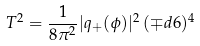Convert formula to latex. <formula><loc_0><loc_0><loc_500><loc_500>T ^ { 2 } = \frac { 1 } { 8 \pi ^ { 2 } } | q _ { + } ( \phi ) | ^ { 2 } \, ( \mp d { 6 } ) ^ { 4 }</formula> 